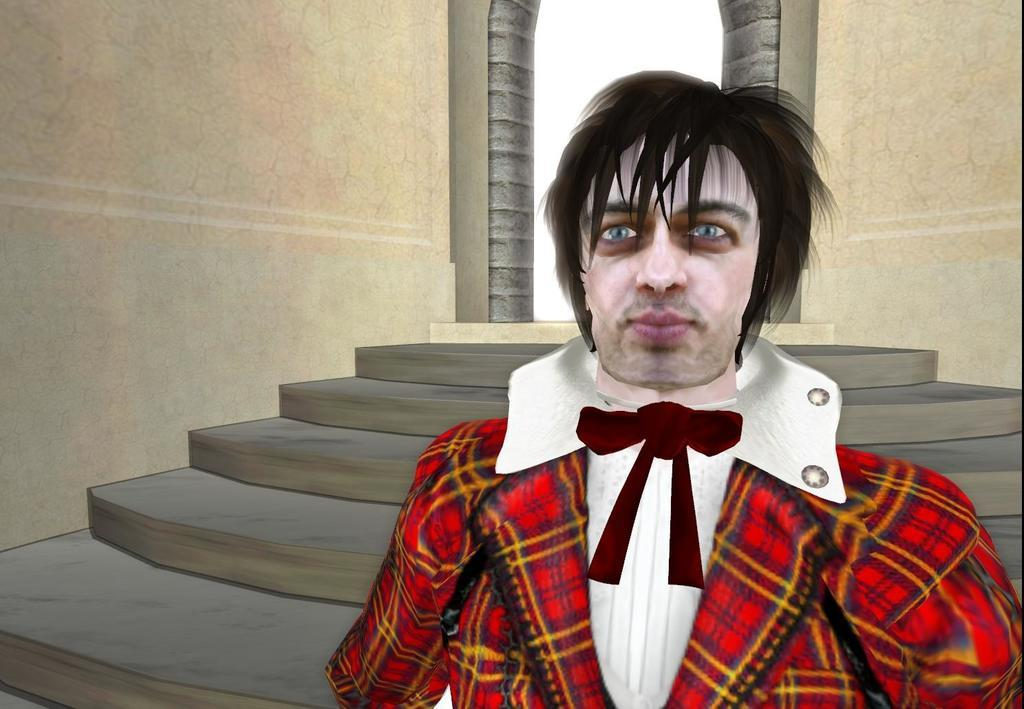What type of picture is in the image? The image contains an animated picture of a person. What is the person wearing in the image? The person is wearing a white and red color dress. What architectural features can be seen in the background of the image? There are stairs, a door, and a wall in the background of the image. What type of wood is used to make the seed in the image? There is no wood or seed present in the image. How does the wave affect the person in the image? There is no wave present in the image; it is an animated picture of a person standing still. 